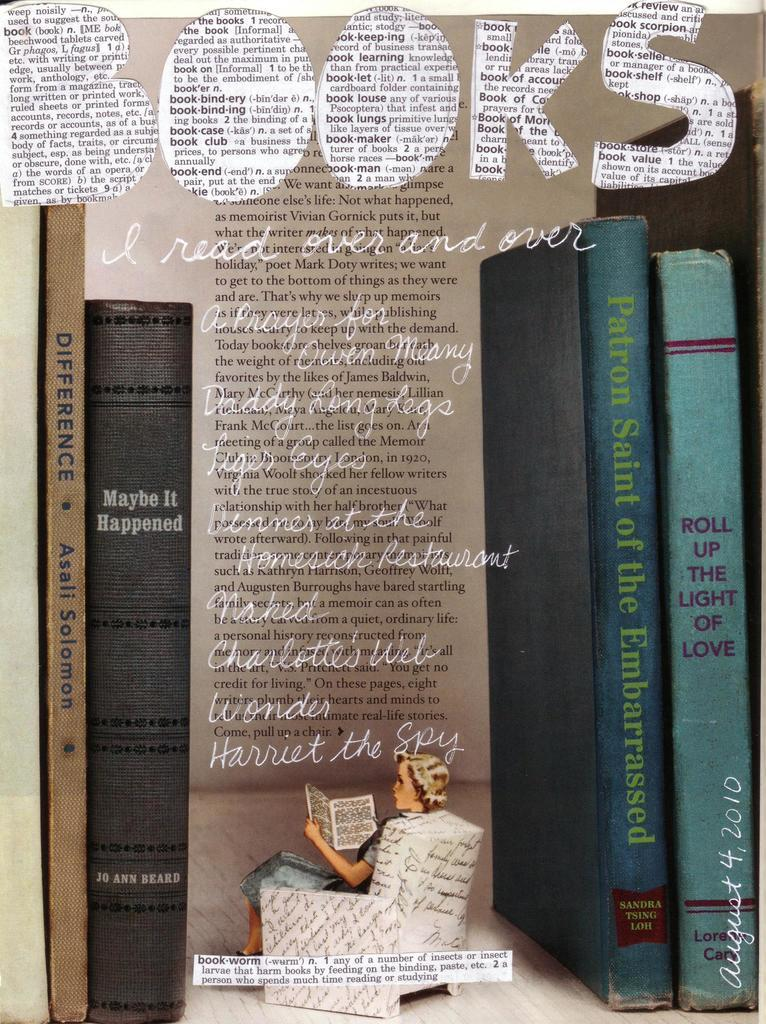<image>
Create a compact narrative representing the image presented. An advertisement for books with a woman reading a book on the front. 